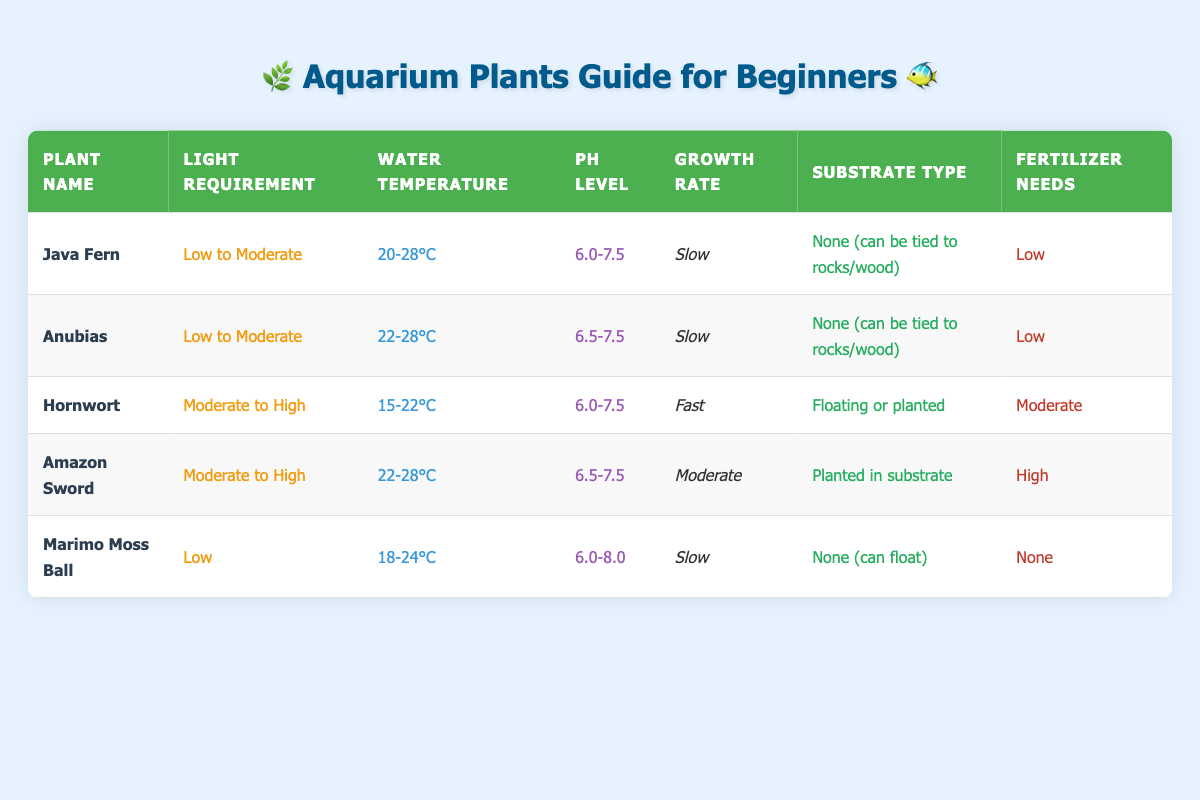What are the light requirements for the Amazon Sword? Looking at the "Light Requirement" column for the Amazon Sword, it states "Moderate to High."
Answer: Moderate to High Which plant has the fastest growth rate? By examining the "Growth Rate" column, Hornwort is marked as "Fast," while others are "Slow" or "Moderate."
Answer: Hornwort Is the Marimo Moss Ball suitable for low light conditions? The "Light Requirement" for Marimo Moss Ball specifies "Low," which confirms it can thrive in low light.
Answer: Yes What is the pH level range for Hornwort? The "pH Level" column indicates for Hornwort, the range is "6.0-7.5." Thus, that is its pH preference.
Answer: 6.0-7.5 How many plants have low fertilizer needs? Looking at the "Fertilizer Needs" column; both Java Fern and Anubias indicate "Low," hence a total of 2 plants fulfill this criterion.
Answer: 2 Does any plant require high fertilizer needs at the same time as having a moderate growth rate? Checking both the "Fertilizer Needs" and "Growth Rate" columns, Amazon Sword has "High" fertilizer needs and a "Moderate" growth rate, confirming this condition.
Answer: Yes What is the average water temperature for plants requiring moderate to high light? There are two plants (Hornwort and Amazon Sword) with moderate to high light requirements and their temperatures are 15-22°C and 22-28°C. Average computation is (22 + 15 + 28 + 22) / 4 = 21.75°C.
Answer: 21.75°C Which plant can float and has low light requirements? By cross-referencing the "Light Requirement" and "Substrate Type" columns, the Marimo Moss Ball fits both criteria: it can float and has "Low" light requirements.
Answer: Marimo Moss Ball What is the growth rate of the Anubias? In the "Growth Rate" column for Anubias, it clearly states "Slow."
Answer: Slow 